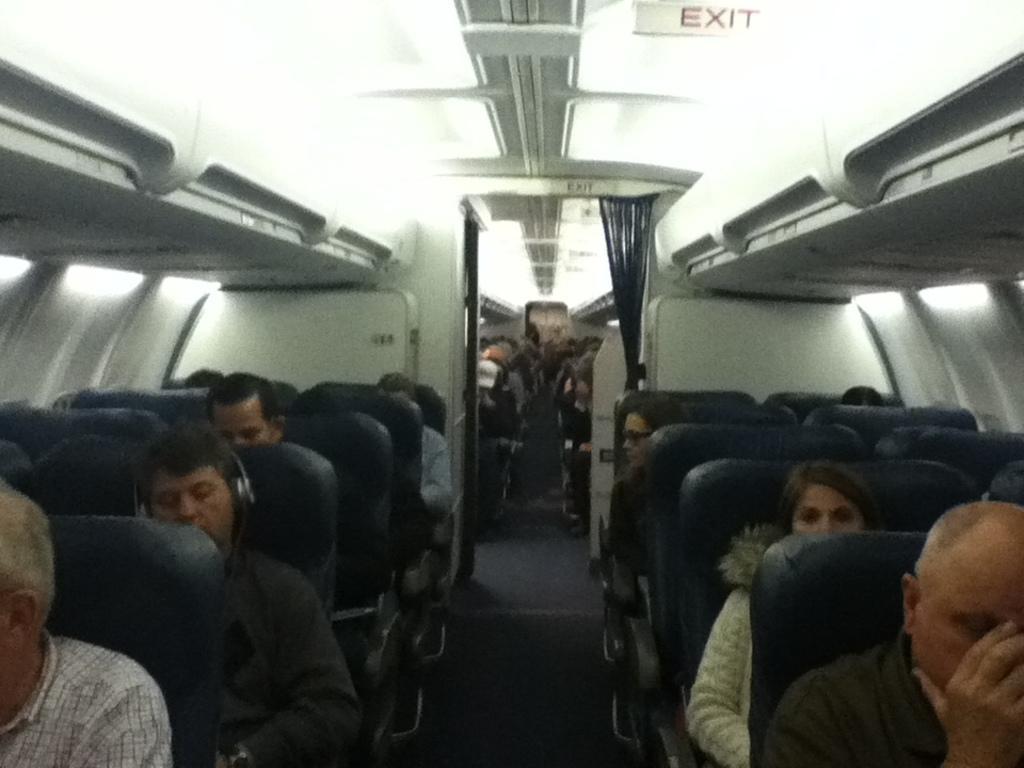Describe this image in one or two sentences. This is inside view of a plane. We can see few people sitting on the chairs and there are lights on the roof top,exit board and curtains. 